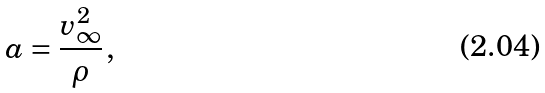<formula> <loc_0><loc_0><loc_500><loc_500>a = \frac { v _ { \infty } ^ { 2 } } { \rho } \, ,</formula> 